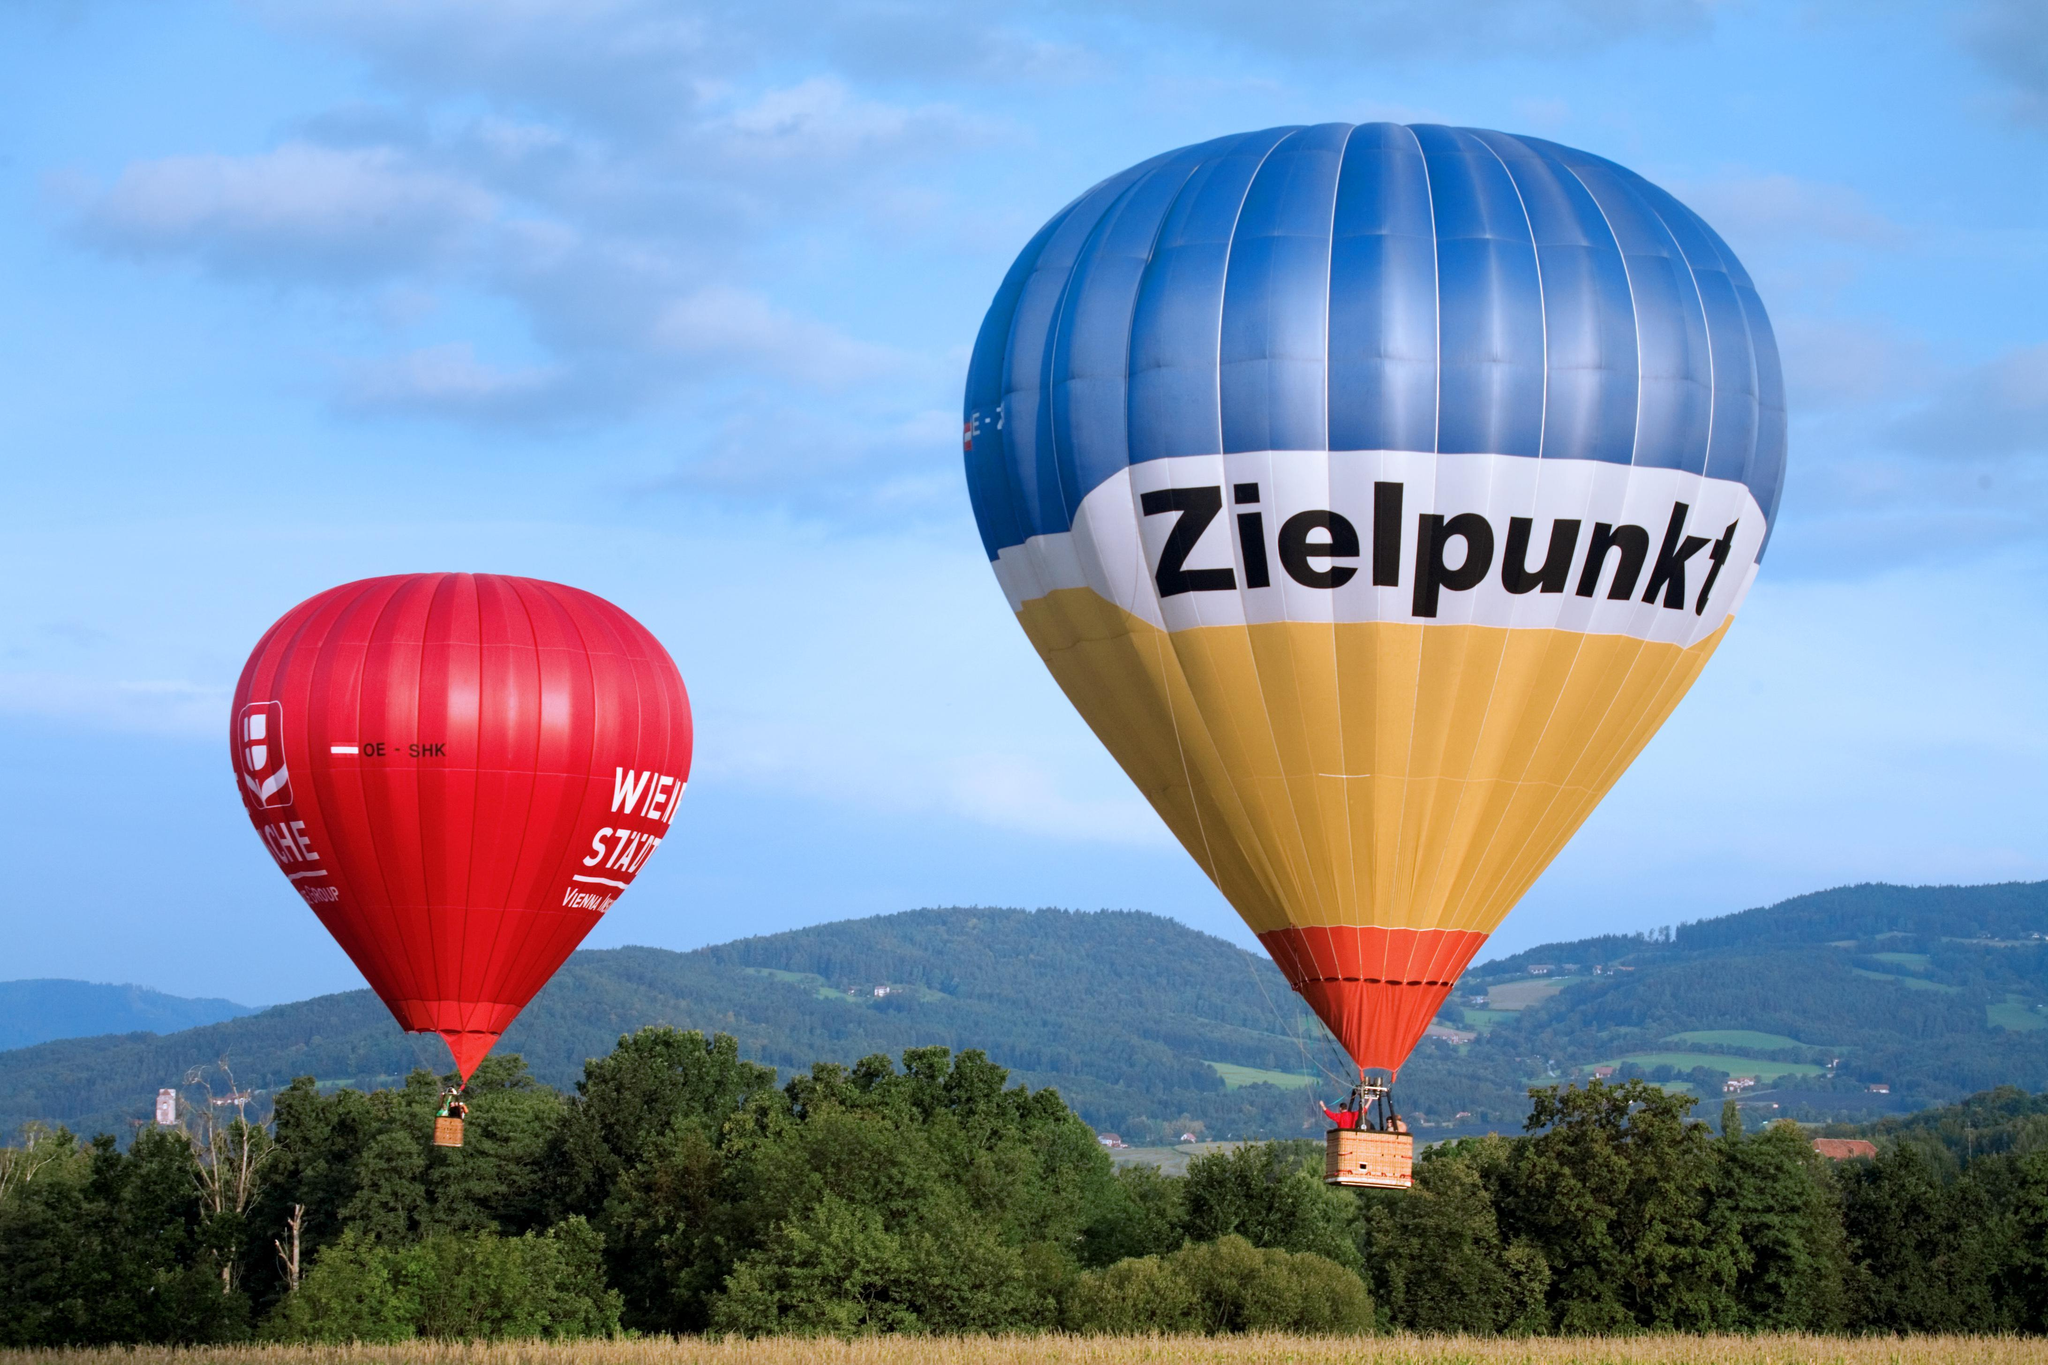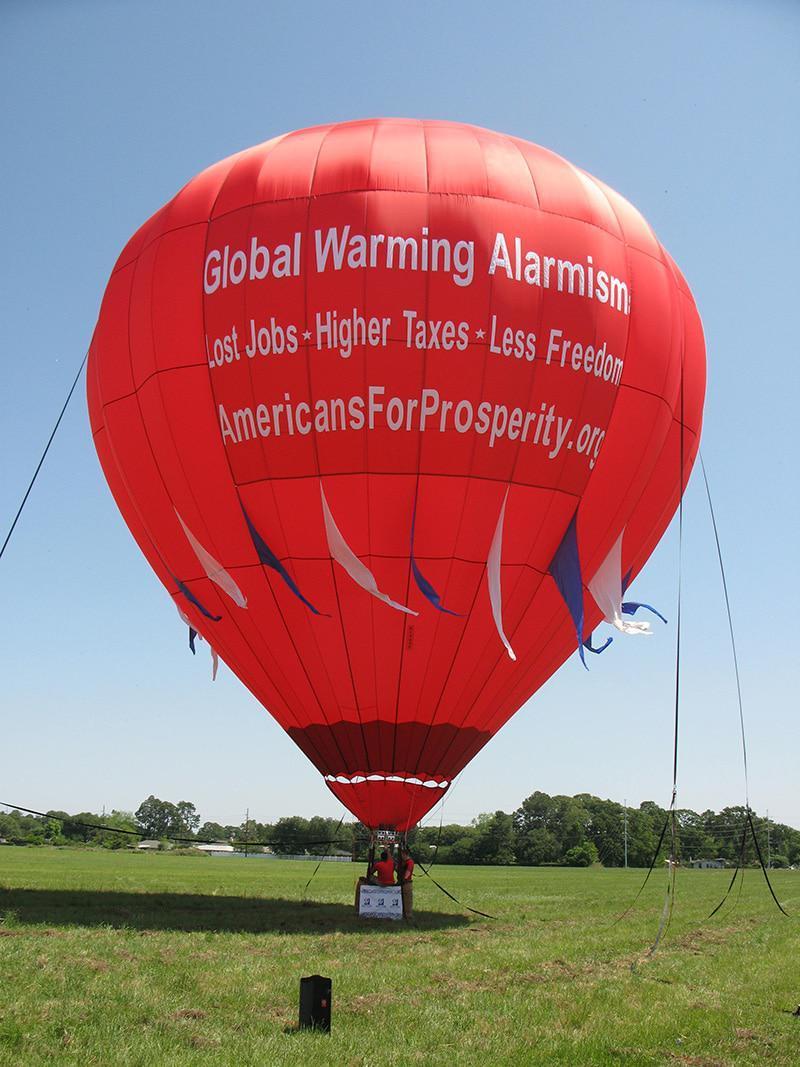The first image is the image on the left, the second image is the image on the right. For the images shown, is this caption "Two hot air balloons with baskets are floating above ground." true? Answer yes or no. Yes. 